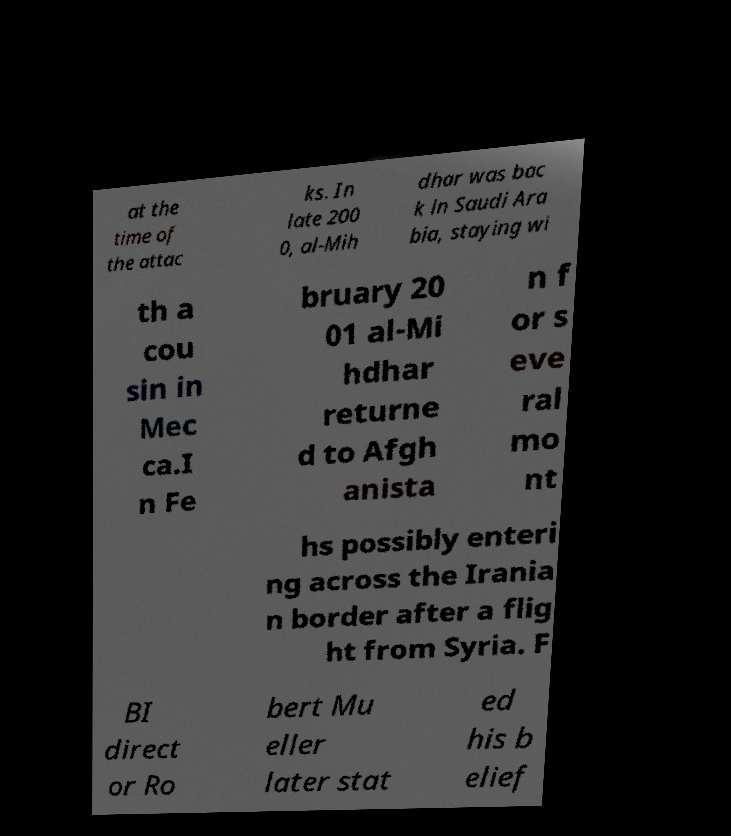Can you read and provide the text displayed in the image?This photo seems to have some interesting text. Can you extract and type it out for me? at the time of the attac ks. In late 200 0, al-Mih dhar was bac k in Saudi Ara bia, staying wi th a cou sin in Mec ca.I n Fe bruary 20 01 al-Mi hdhar returne d to Afgh anista n f or s eve ral mo nt hs possibly enteri ng across the Irania n border after a flig ht from Syria. F BI direct or Ro bert Mu eller later stat ed his b elief 